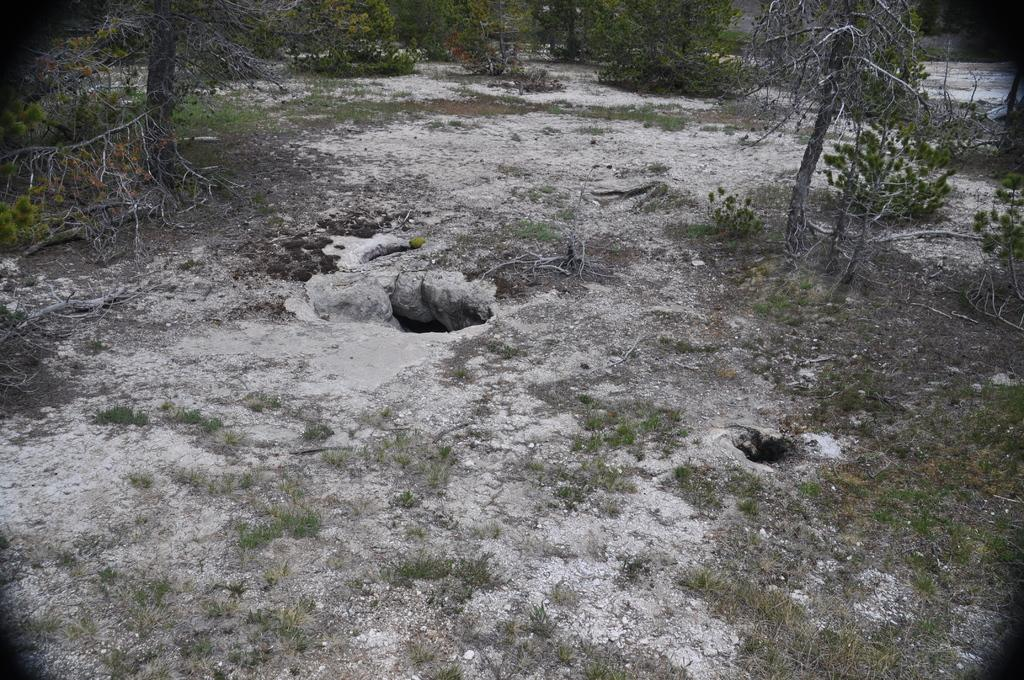What type of vegetation can be seen in the image? There are trees and plants in the image. What is covering the ground in the image? There is grass on the ground in the image. What type of spade is being used to dig up the plants in the image? There is no spade present in the image; it only features trees, plants, and grass. How many servants can be seen attending to the plants in the image? There are no servants present in the image; it only features trees, plants, and grass. 